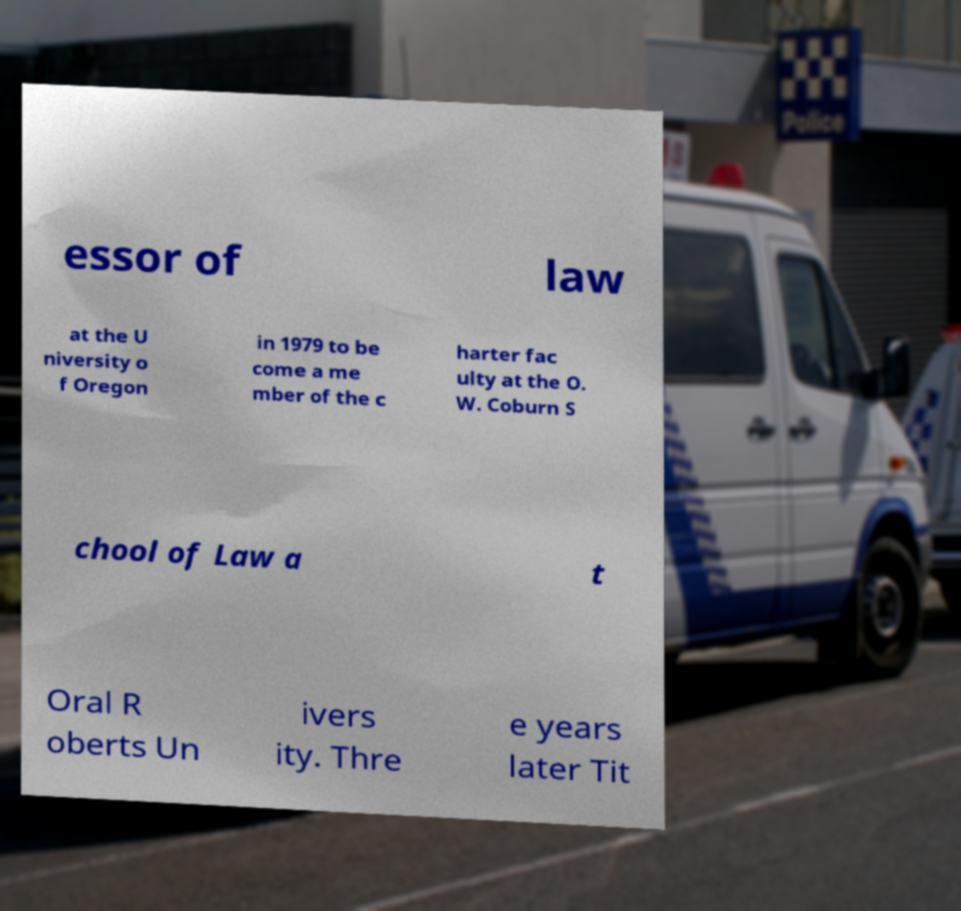I need the written content from this picture converted into text. Can you do that? essor of law at the U niversity o f Oregon in 1979 to be come a me mber of the c harter fac ulty at the O. W. Coburn S chool of Law a t Oral R oberts Un ivers ity. Thre e years later Tit 